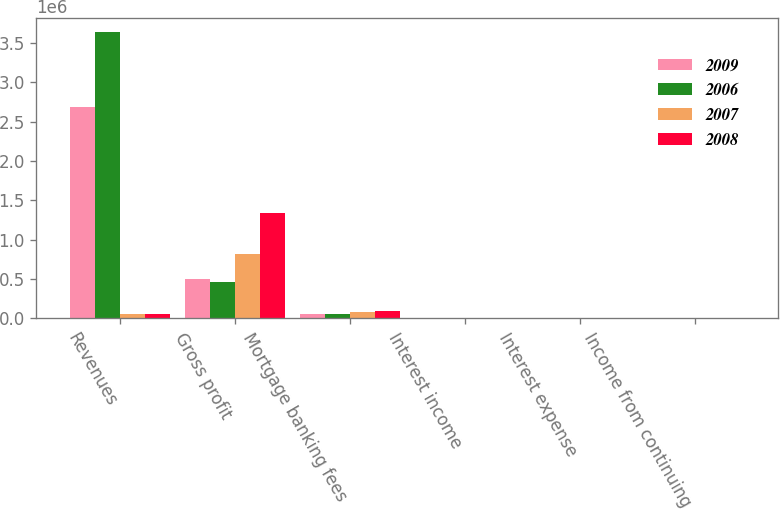Convert chart. <chart><loc_0><loc_0><loc_500><loc_500><stacked_bar_chart><ecel><fcel>Revenues<fcel>Gross profit<fcel>Mortgage banking fees<fcel>Interest income<fcel>Interest expense<fcel>Income from continuing<nl><fcel>2009<fcel>2.68347e+06<fcel>497734<fcel>60381<fcel>2979<fcel>1184<fcel>31.26<nl><fcel>2006<fcel>3.6387e+06<fcel>457692<fcel>54337<fcel>3955<fcel>754<fcel>17.04<nl><fcel>2007<fcel>57359<fcel>821128<fcel>81155<fcel>4900<fcel>681<fcel>54.14<nl><fcel>2008<fcel>57359<fcel>1.33497e+06<fcel>97888<fcel>7704<fcel>2805<fcel>88.05<nl></chart> 